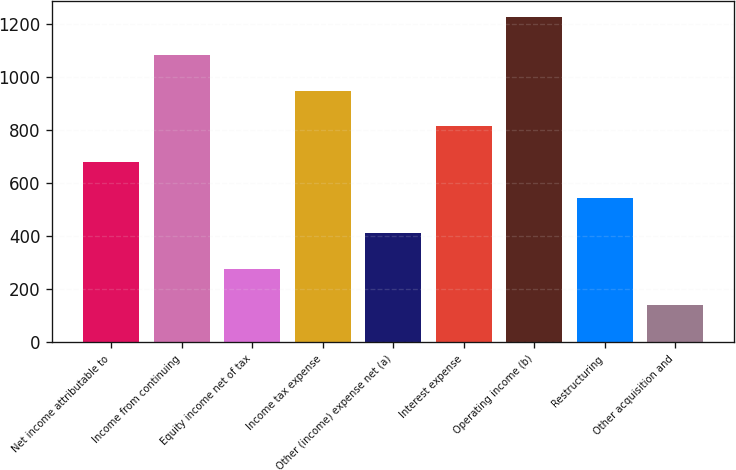Convert chart. <chart><loc_0><loc_0><loc_500><loc_500><bar_chart><fcel>Net income attributable to<fcel>Income from continuing<fcel>Equity income net of tax<fcel>Income tax expense<fcel>Other (income) expense net (a)<fcel>Interest expense<fcel>Operating income (b)<fcel>Restructuring<fcel>Other acquisition and<nl><fcel>679<fcel>1082.2<fcel>275.8<fcel>947.8<fcel>410.2<fcel>813.4<fcel>1225<fcel>544.6<fcel>141.4<nl></chart> 